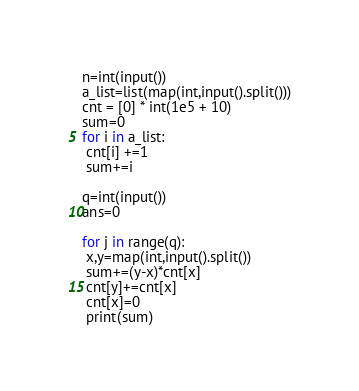<code> <loc_0><loc_0><loc_500><loc_500><_Python_>n=int(input())
a_list=list(map(int,input().split()))
cnt = [0] * int(1e5 + 10)
sum=0
for i in a_list:
 cnt[i] +=1
 sum+=i
  
q=int(input())
ans=0
 
for j in range(q):
 x,y=map(int,input().split())
 sum+=(y-x)*cnt[x]
 cnt[y]+=cnt[x]
 cnt[x]=0
 print(sum)</code> 